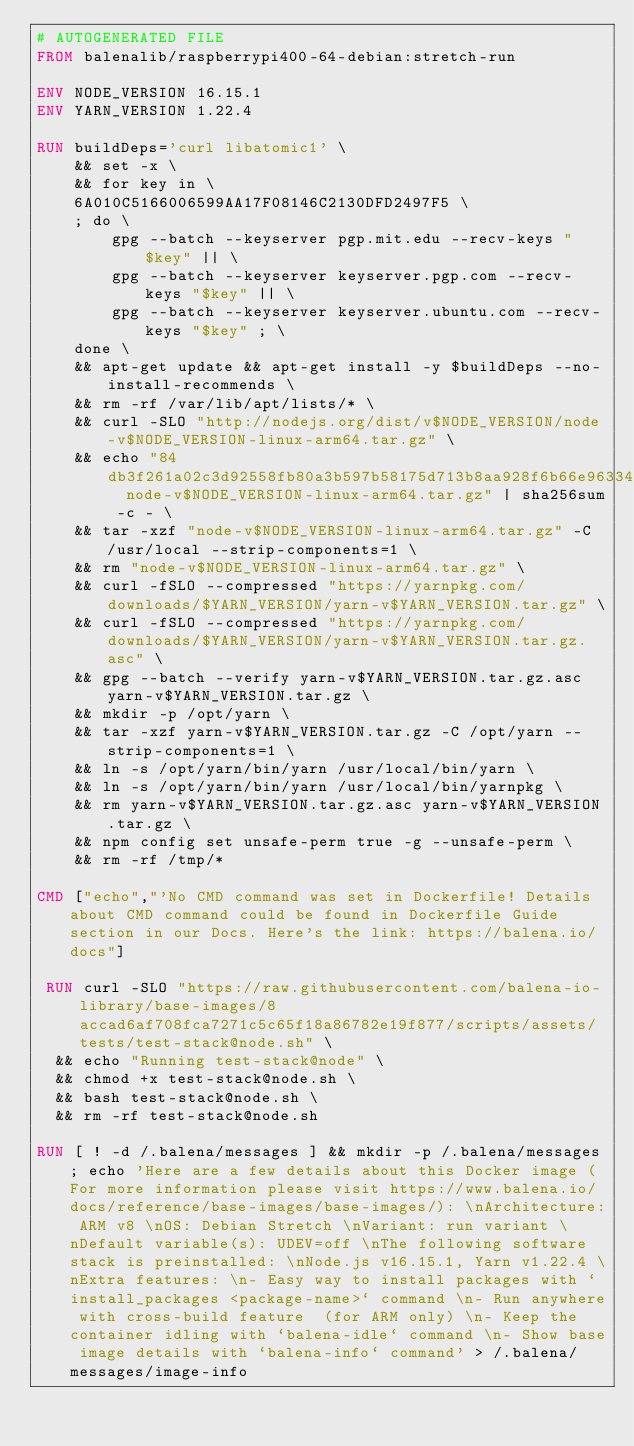Convert code to text. <code><loc_0><loc_0><loc_500><loc_500><_Dockerfile_># AUTOGENERATED FILE
FROM balenalib/raspberrypi400-64-debian:stretch-run

ENV NODE_VERSION 16.15.1
ENV YARN_VERSION 1.22.4

RUN buildDeps='curl libatomic1' \
	&& set -x \
	&& for key in \
	6A010C5166006599AA17F08146C2130DFD2497F5 \
	; do \
		gpg --batch --keyserver pgp.mit.edu --recv-keys "$key" || \
		gpg --batch --keyserver keyserver.pgp.com --recv-keys "$key" || \
		gpg --batch --keyserver keyserver.ubuntu.com --recv-keys "$key" ; \
	done \
	&& apt-get update && apt-get install -y $buildDeps --no-install-recommends \
	&& rm -rf /var/lib/apt/lists/* \
	&& curl -SLO "http://nodejs.org/dist/v$NODE_VERSION/node-v$NODE_VERSION-linux-arm64.tar.gz" \
	&& echo "84db3f261a02c3d92558fb80a3b597b58175d713b8aa928f6b66e963340f1faf  node-v$NODE_VERSION-linux-arm64.tar.gz" | sha256sum -c - \
	&& tar -xzf "node-v$NODE_VERSION-linux-arm64.tar.gz" -C /usr/local --strip-components=1 \
	&& rm "node-v$NODE_VERSION-linux-arm64.tar.gz" \
	&& curl -fSLO --compressed "https://yarnpkg.com/downloads/$YARN_VERSION/yarn-v$YARN_VERSION.tar.gz" \
	&& curl -fSLO --compressed "https://yarnpkg.com/downloads/$YARN_VERSION/yarn-v$YARN_VERSION.tar.gz.asc" \
	&& gpg --batch --verify yarn-v$YARN_VERSION.tar.gz.asc yarn-v$YARN_VERSION.tar.gz \
	&& mkdir -p /opt/yarn \
	&& tar -xzf yarn-v$YARN_VERSION.tar.gz -C /opt/yarn --strip-components=1 \
	&& ln -s /opt/yarn/bin/yarn /usr/local/bin/yarn \
	&& ln -s /opt/yarn/bin/yarn /usr/local/bin/yarnpkg \
	&& rm yarn-v$YARN_VERSION.tar.gz.asc yarn-v$YARN_VERSION.tar.gz \
	&& npm config set unsafe-perm true -g --unsafe-perm \
	&& rm -rf /tmp/*

CMD ["echo","'No CMD command was set in Dockerfile! Details about CMD command could be found in Dockerfile Guide section in our Docs. Here's the link: https://balena.io/docs"]

 RUN curl -SLO "https://raw.githubusercontent.com/balena-io-library/base-images/8accad6af708fca7271c5c65f18a86782e19f877/scripts/assets/tests/test-stack@node.sh" \
  && echo "Running test-stack@node" \
  && chmod +x test-stack@node.sh \
  && bash test-stack@node.sh \
  && rm -rf test-stack@node.sh 

RUN [ ! -d /.balena/messages ] && mkdir -p /.balena/messages; echo 'Here are a few details about this Docker image (For more information please visit https://www.balena.io/docs/reference/base-images/base-images/): \nArchitecture: ARM v8 \nOS: Debian Stretch \nVariant: run variant \nDefault variable(s): UDEV=off \nThe following software stack is preinstalled: \nNode.js v16.15.1, Yarn v1.22.4 \nExtra features: \n- Easy way to install packages with `install_packages <package-name>` command \n- Run anywhere with cross-build feature  (for ARM only) \n- Keep the container idling with `balena-idle` command \n- Show base image details with `balena-info` command' > /.balena/messages/image-info</code> 